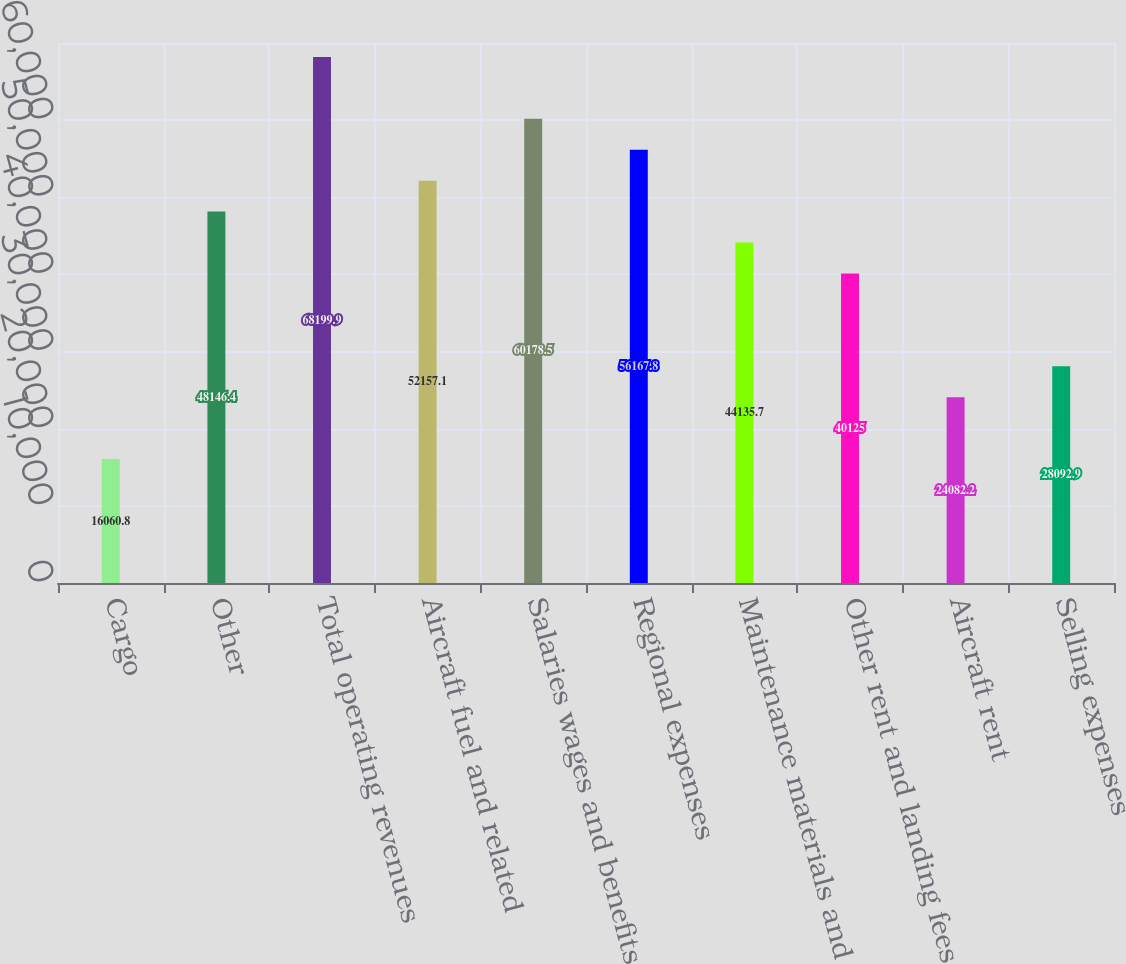Convert chart to OTSL. <chart><loc_0><loc_0><loc_500><loc_500><bar_chart><fcel>Cargo<fcel>Other<fcel>Total operating revenues<fcel>Aircraft fuel and related<fcel>Salaries wages and benefits<fcel>Regional expenses<fcel>Maintenance materials and<fcel>Other rent and landing fees<fcel>Aircraft rent<fcel>Selling expenses<nl><fcel>16060.8<fcel>48146.4<fcel>68199.9<fcel>52157.1<fcel>60178.5<fcel>56167.8<fcel>44135.7<fcel>40125<fcel>24082.2<fcel>28092.9<nl></chart> 